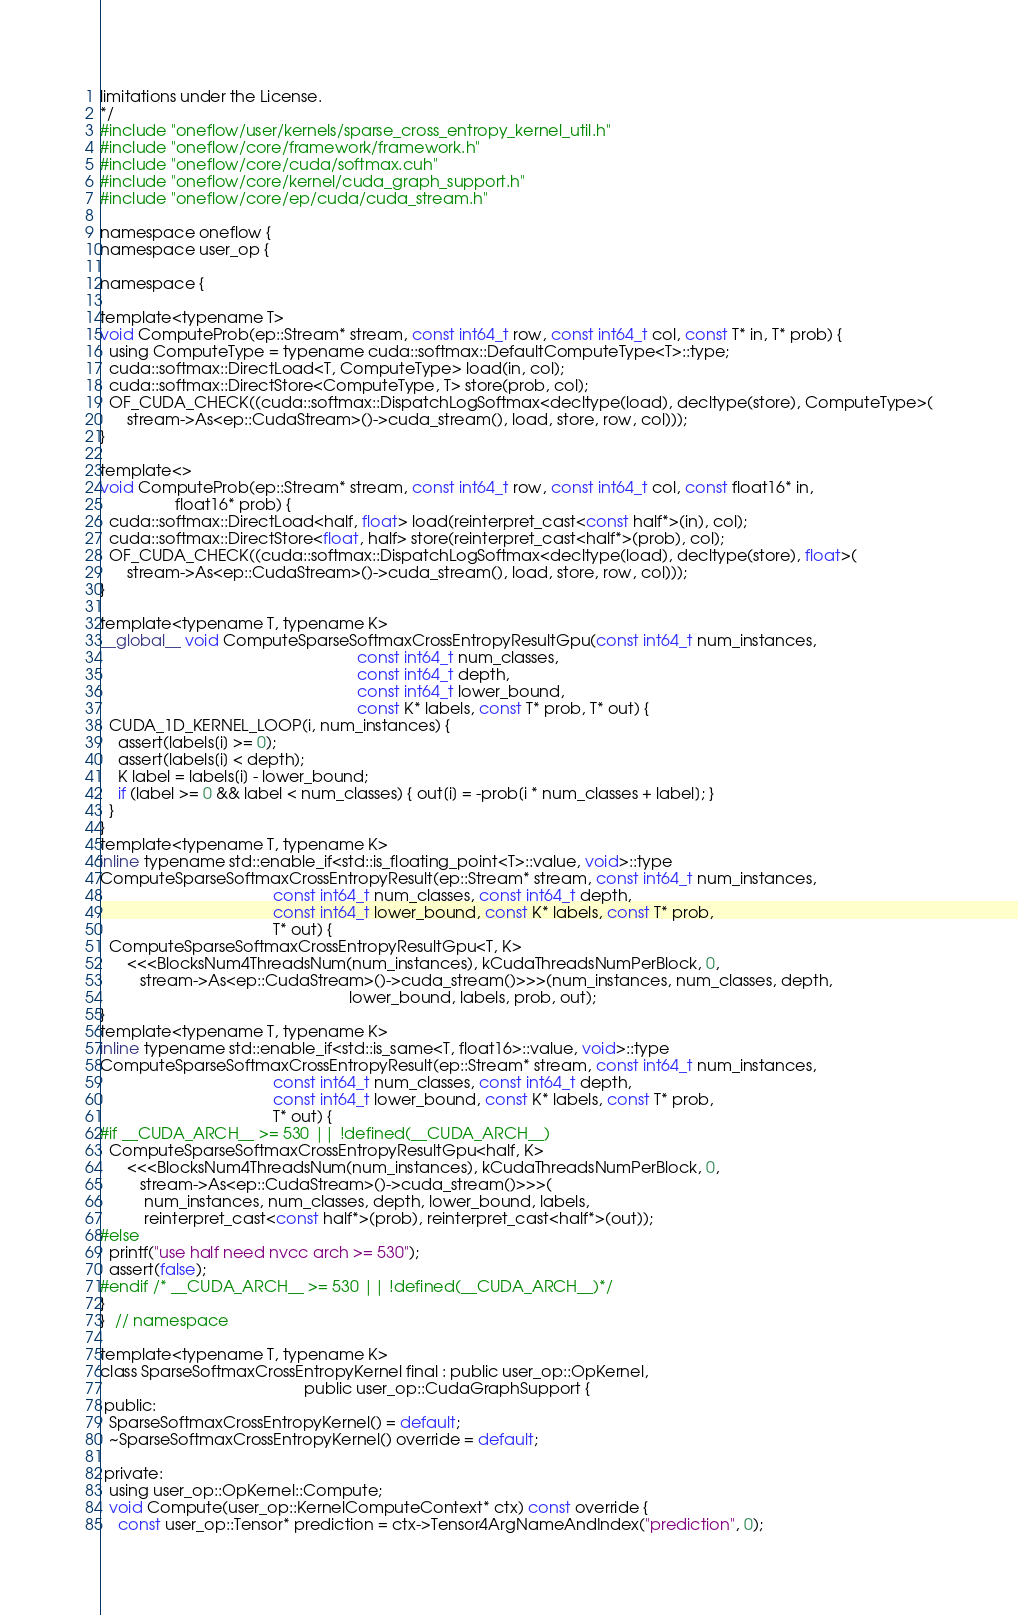<code> <loc_0><loc_0><loc_500><loc_500><_Cuda_>limitations under the License.
*/
#include "oneflow/user/kernels/sparse_cross_entropy_kernel_util.h"
#include "oneflow/core/framework/framework.h"
#include "oneflow/core/cuda/softmax.cuh"
#include "oneflow/core/kernel/cuda_graph_support.h"
#include "oneflow/core/ep/cuda/cuda_stream.h"

namespace oneflow {
namespace user_op {

namespace {

template<typename T>
void ComputeProb(ep::Stream* stream, const int64_t row, const int64_t col, const T* in, T* prob) {
  using ComputeType = typename cuda::softmax::DefaultComputeType<T>::type;
  cuda::softmax::DirectLoad<T, ComputeType> load(in, col);
  cuda::softmax::DirectStore<ComputeType, T> store(prob, col);
  OF_CUDA_CHECK((cuda::softmax::DispatchLogSoftmax<decltype(load), decltype(store), ComputeType>(
      stream->As<ep::CudaStream>()->cuda_stream(), load, store, row, col)));
}

template<>
void ComputeProb(ep::Stream* stream, const int64_t row, const int64_t col, const float16* in,
                 float16* prob) {
  cuda::softmax::DirectLoad<half, float> load(reinterpret_cast<const half*>(in), col);
  cuda::softmax::DirectStore<float, half> store(reinterpret_cast<half*>(prob), col);
  OF_CUDA_CHECK((cuda::softmax::DispatchLogSoftmax<decltype(load), decltype(store), float>(
      stream->As<ep::CudaStream>()->cuda_stream(), load, store, row, col)));
}

template<typename T, typename K>
__global__ void ComputeSparseSoftmaxCrossEntropyResultGpu(const int64_t num_instances,
                                                          const int64_t num_classes,
                                                          const int64_t depth,
                                                          const int64_t lower_bound,
                                                          const K* labels, const T* prob, T* out) {
  CUDA_1D_KERNEL_LOOP(i, num_instances) {
    assert(labels[i] >= 0);
    assert(labels[i] < depth);
    K label = labels[i] - lower_bound;
    if (label >= 0 && label < num_classes) { out[i] = -prob[i * num_classes + label]; }
  }
}
template<typename T, typename K>
inline typename std::enable_if<std::is_floating_point<T>::value, void>::type
ComputeSparseSoftmaxCrossEntropyResult(ep::Stream* stream, const int64_t num_instances,
                                       const int64_t num_classes, const int64_t depth,
                                       const int64_t lower_bound, const K* labels, const T* prob,
                                       T* out) {
  ComputeSparseSoftmaxCrossEntropyResultGpu<T, K>
      <<<BlocksNum4ThreadsNum(num_instances), kCudaThreadsNumPerBlock, 0,
         stream->As<ep::CudaStream>()->cuda_stream()>>>(num_instances, num_classes, depth,
                                                        lower_bound, labels, prob, out);
}
template<typename T, typename K>
inline typename std::enable_if<std::is_same<T, float16>::value, void>::type
ComputeSparseSoftmaxCrossEntropyResult(ep::Stream* stream, const int64_t num_instances,
                                       const int64_t num_classes, const int64_t depth,
                                       const int64_t lower_bound, const K* labels, const T* prob,
                                       T* out) {
#if __CUDA_ARCH__ >= 530 || !defined(__CUDA_ARCH__)
  ComputeSparseSoftmaxCrossEntropyResultGpu<half, K>
      <<<BlocksNum4ThreadsNum(num_instances), kCudaThreadsNumPerBlock, 0,
         stream->As<ep::CudaStream>()->cuda_stream()>>>(
          num_instances, num_classes, depth, lower_bound, labels,
          reinterpret_cast<const half*>(prob), reinterpret_cast<half*>(out));
#else
  printf("use half need nvcc arch >= 530");
  assert(false);
#endif /* __CUDA_ARCH__ >= 530 || !defined(__CUDA_ARCH__)*/
}
}  // namespace

template<typename T, typename K>
class SparseSoftmaxCrossEntropyKernel final : public user_op::OpKernel,
                                              public user_op::CudaGraphSupport {
 public:
  SparseSoftmaxCrossEntropyKernel() = default;
  ~SparseSoftmaxCrossEntropyKernel() override = default;

 private:
  using user_op::OpKernel::Compute;
  void Compute(user_op::KernelComputeContext* ctx) const override {
    const user_op::Tensor* prediction = ctx->Tensor4ArgNameAndIndex("prediction", 0);</code> 